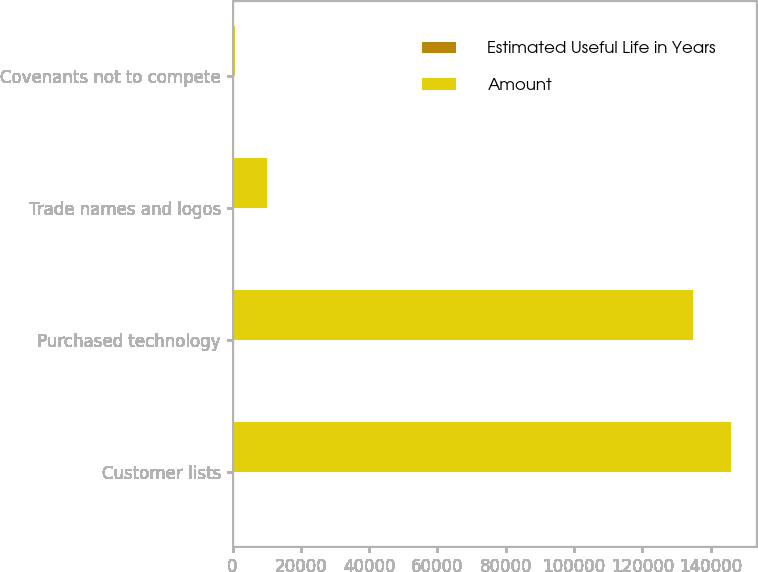Convert chart to OTSL. <chart><loc_0><loc_0><loc_500><loc_500><stacked_bar_chart><ecel><fcel>Customer lists<fcel>Purchased technology<fcel>Trade names and logos<fcel>Covenants not to compete<nl><fcel>Estimated Useful Life in Years<fcel>5<fcel>3<fcel>5<fcel>3<nl><fcel>Amount<fcel>146000<fcel>134800<fcel>10000<fcel>700<nl></chart> 